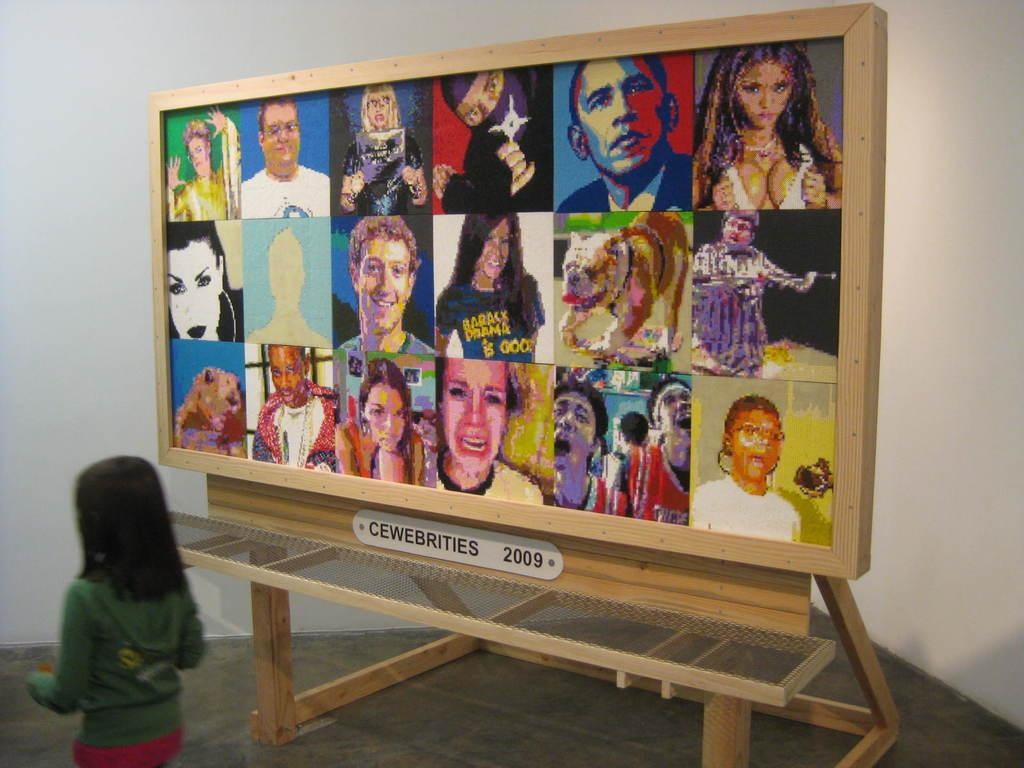What is located on the left side of the image? There is a girl on the left side of the image. What can be seen in the background of the image? There are depictions on a board in the background of the image. How many times does the girl jump in the image? There is no indication in the image that the girl is jumping, so it cannot be determined from the picture. 